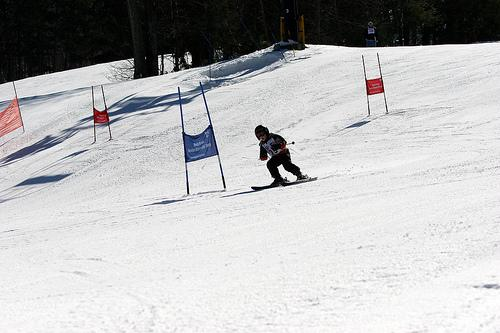What specific details about the skier's lower body can you depict from the image? The skier's legs are bent at the knees, and he is wearing skis and dark bottom pants. Mention any specific identifiers for the skier seen in the image. The skier is wearing a white bib with identifying marks on it for the contest. What is the role of the markers present in the image? The markers in the image guide skiers through the downhill slalom racecourse. Describe the area surrounding the skier in the image. The skier is in a snowy field with markers, shadows, ski tracks, and trees at the edges of the course. What kind of terrain is the skier navigating, and what do you see at the edges of the course? The skier is navigating a snow-covered hillside on hard-packed snow, with trees at the edge of the course and a fence at the course's boundary. Can you specify the colors of the markers seen on the hillside for guiding skiers? There are red and blue gates or markers on the hillside to guide skiers. Describe how the man's outfit is represented in this image. The man is wearing a hat and a coat while skiing, he's dressed in black clothes, including a jacket and dark bottom pants. What is the primary objective of the contestant in the image? The contestant's primary objective is to participate in a downhill slalom ski race and navigate through the course markers. What is the position of the skier in relation to the markers in the image? The skier is skiing down between the markers in the course while maintaining correct form. How many signs of different colors can be seen on the hill, and what are their colors? There are two colored signs on the hill - red and blue. 